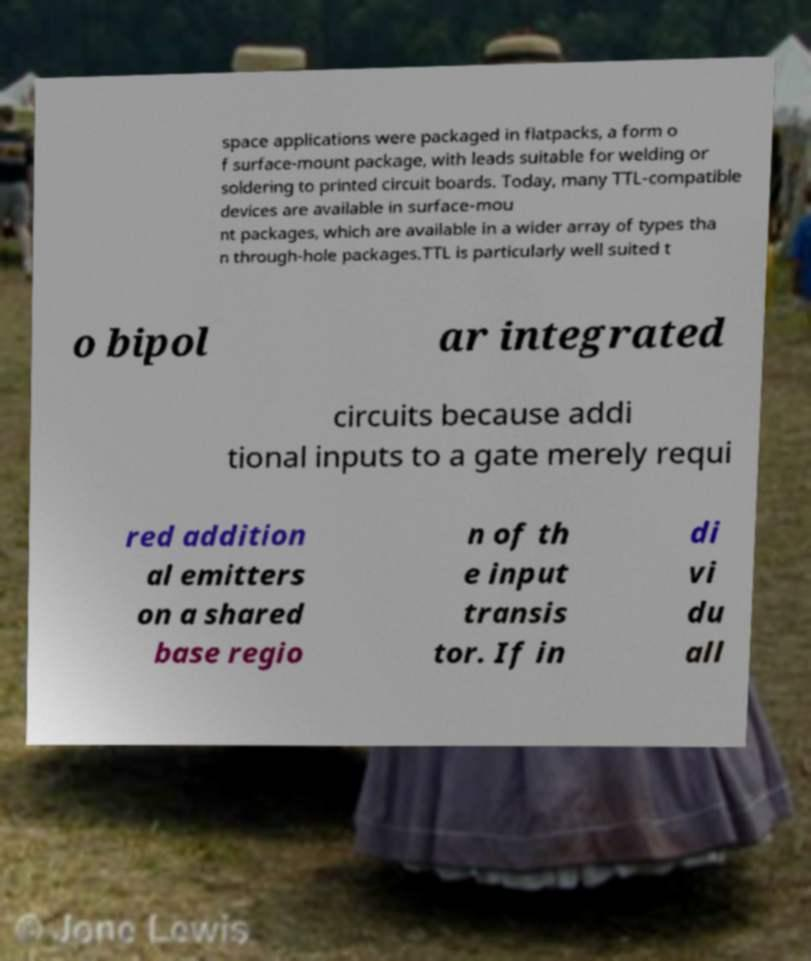For documentation purposes, I need the text within this image transcribed. Could you provide that? space applications were packaged in flatpacks, a form o f surface-mount package, with leads suitable for welding or soldering to printed circuit boards. Today, many TTL-compatible devices are available in surface-mou nt packages, which are available in a wider array of types tha n through-hole packages.TTL is particularly well suited t o bipol ar integrated circuits because addi tional inputs to a gate merely requi red addition al emitters on a shared base regio n of th e input transis tor. If in di vi du all 